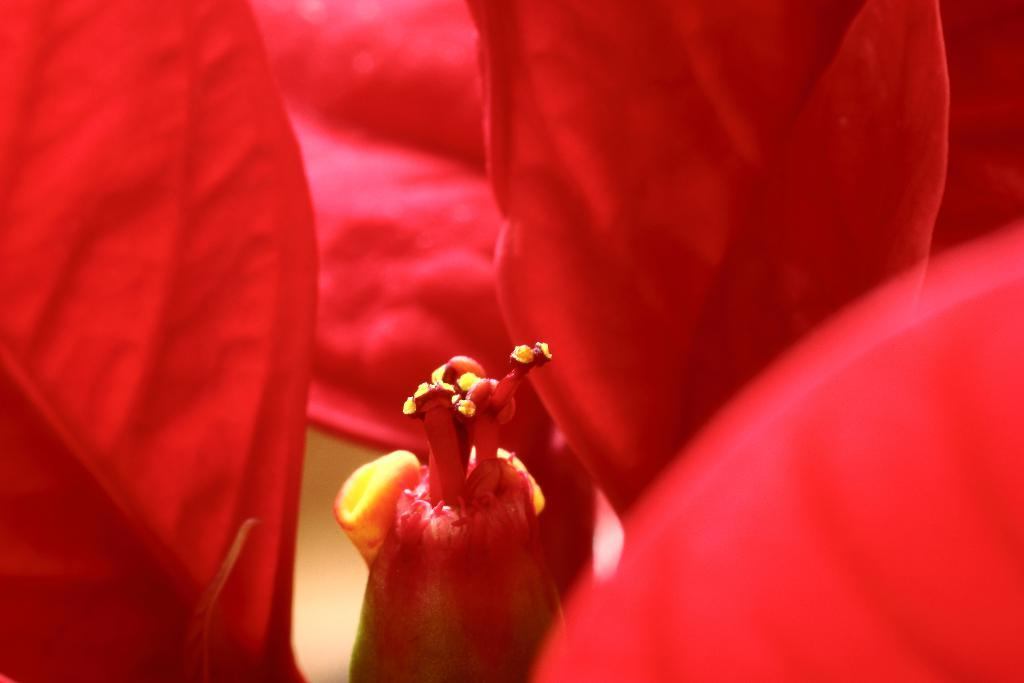What is the focus of the image? The image is a zoomed in picture of a red color flower. Can you describe the flower in the image? The flower in the image is red in color. What type of amusement can be seen in the image? There is no amusement present in the image; it is a close-up picture of a red color flower. What wire is connected to the flower in the image? There is no wire connected to the flower in the image; it is a standalone flower. 